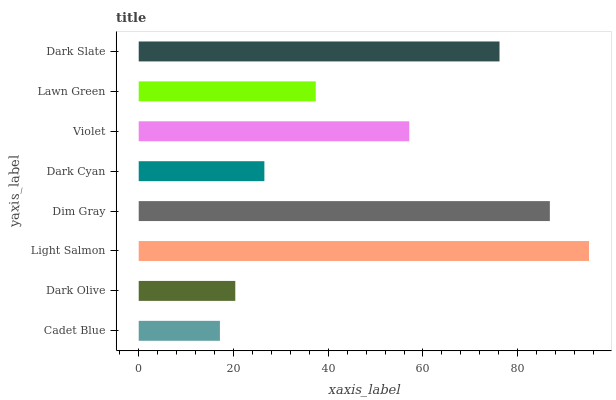Is Cadet Blue the minimum?
Answer yes or no. Yes. Is Light Salmon the maximum?
Answer yes or no. Yes. Is Dark Olive the minimum?
Answer yes or no. No. Is Dark Olive the maximum?
Answer yes or no. No. Is Dark Olive greater than Cadet Blue?
Answer yes or no. Yes. Is Cadet Blue less than Dark Olive?
Answer yes or no. Yes. Is Cadet Blue greater than Dark Olive?
Answer yes or no. No. Is Dark Olive less than Cadet Blue?
Answer yes or no. No. Is Violet the high median?
Answer yes or no. Yes. Is Lawn Green the low median?
Answer yes or no. Yes. Is Light Salmon the high median?
Answer yes or no. No. Is Dark Cyan the low median?
Answer yes or no. No. 